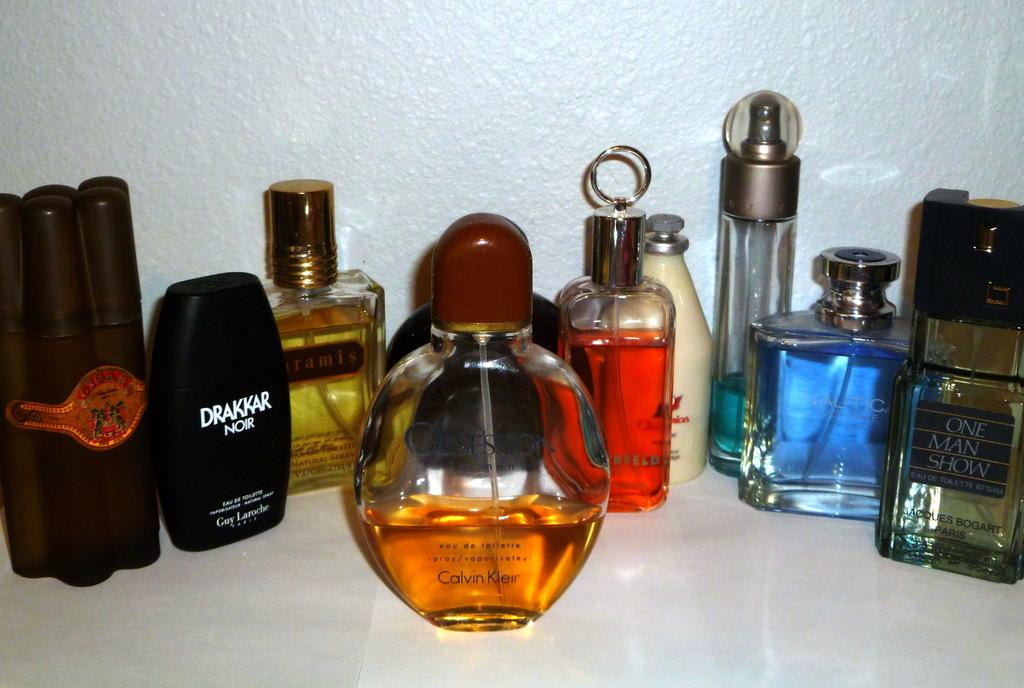<image>
Create a compact narrative representing the image presented. Bottles of cologne with a black bottle saying 'Drakkar Noir". 